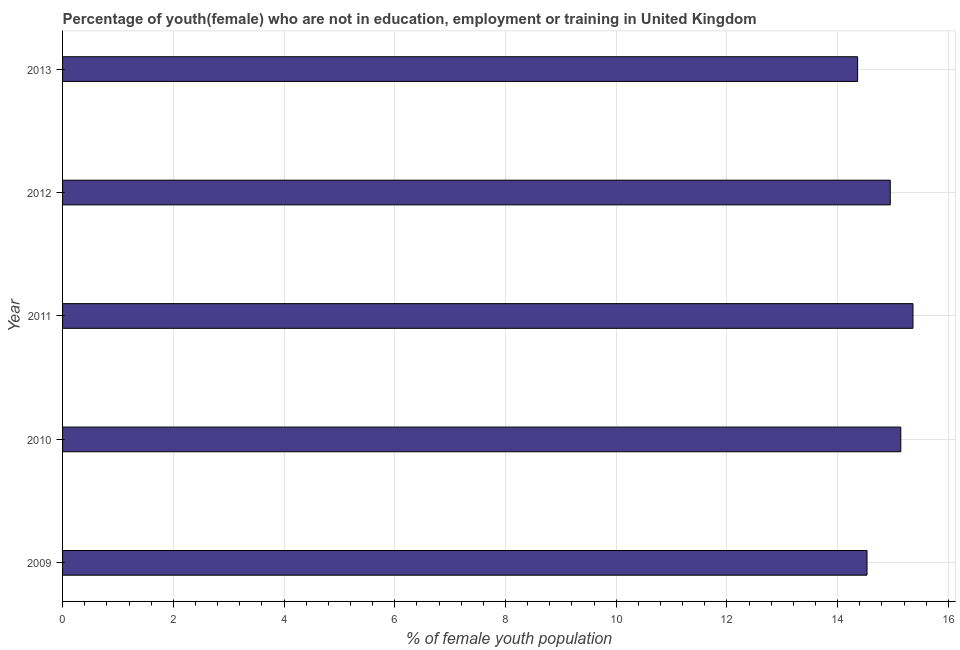What is the title of the graph?
Your answer should be compact. Percentage of youth(female) who are not in education, employment or training in United Kingdom. What is the label or title of the X-axis?
Ensure brevity in your answer.  % of female youth population. What is the unemployed female youth population in 2012?
Ensure brevity in your answer.  14.95. Across all years, what is the maximum unemployed female youth population?
Provide a succinct answer. 15.36. Across all years, what is the minimum unemployed female youth population?
Your response must be concise. 14.36. In which year was the unemployed female youth population maximum?
Your response must be concise. 2011. What is the sum of the unemployed female youth population?
Your answer should be very brief. 74.34. What is the difference between the unemployed female youth population in 2009 and 2010?
Offer a very short reply. -0.61. What is the average unemployed female youth population per year?
Offer a very short reply. 14.87. What is the median unemployed female youth population?
Give a very brief answer. 14.95. Do a majority of the years between 2009 and 2011 (inclusive) have unemployed female youth population greater than 7.2 %?
Provide a short and direct response. Yes. Is the unemployed female youth population in 2009 less than that in 2011?
Ensure brevity in your answer.  Yes. What is the difference between the highest and the second highest unemployed female youth population?
Ensure brevity in your answer.  0.22. Is the sum of the unemployed female youth population in 2011 and 2012 greater than the maximum unemployed female youth population across all years?
Keep it short and to the point. Yes. What is the difference between the highest and the lowest unemployed female youth population?
Offer a very short reply. 1. How many bars are there?
Give a very brief answer. 5. Are the values on the major ticks of X-axis written in scientific E-notation?
Your answer should be compact. No. What is the % of female youth population in 2009?
Provide a succinct answer. 14.53. What is the % of female youth population in 2010?
Offer a very short reply. 15.14. What is the % of female youth population in 2011?
Offer a terse response. 15.36. What is the % of female youth population in 2012?
Offer a terse response. 14.95. What is the % of female youth population of 2013?
Provide a succinct answer. 14.36. What is the difference between the % of female youth population in 2009 and 2010?
Your response must be concise. -0.61. What is the difference between the % of female youth population in 2009 and 2011?
Your answer should be very brief. -0.83. What is the difference between the % of female youth population in 2009 and 2012?
Provide a short and direct response. -0.42. What is the difference between the % of female youth population in 2009 and 2013?
Provide a short and direct response. 0.17. What is the difference between the % of female youth population in 2010 and 2011?
Offer a terse response. -0.22. What is the difference between the % of female youth population in 2010 and 2012?
Give a very brief answer. 0.19. What is the difference between the % of female youth population in 2010 and 2013?
Provide a short and direct response. 0.78. What is the difference between the % of female youth population in 2011 and 2012?
Ensure brevity in your answer.  0.41. What is the difference between the % of female youth population in 2012 and 2013?
Offer a terse response. 0.59. What is the ratio of the % of female youth population in 2009 to that in 2011?
Your answer should be very brief. 0.95. What is the ratio of the % of female youth population in 2009 to that in 2012?
Offer a very short reply. 0.97. What is the ratio of the % of female youth population in 2009 to that in 2013?
Your answer should be compact. 1.01. What is the ratio of the % of female youth population in 2010 to that in 2011?
Provide a short and direct response. 0.99. What is the ratio of the % of female youth population in 2010 to that in 2013?
Offer a very short reply. 1.05. What is the ratio of the % of female youth population in 2011 to that in 2012?
Offer a very short reply. 1.03. What is the ratio of the % of female youth population in 2011 to that in 2013?
Provide a succinct answer. 1.07. What is the ratio of the % of female youth population in 2012 to that in 2013?
Make the answer very short. 1.04. 